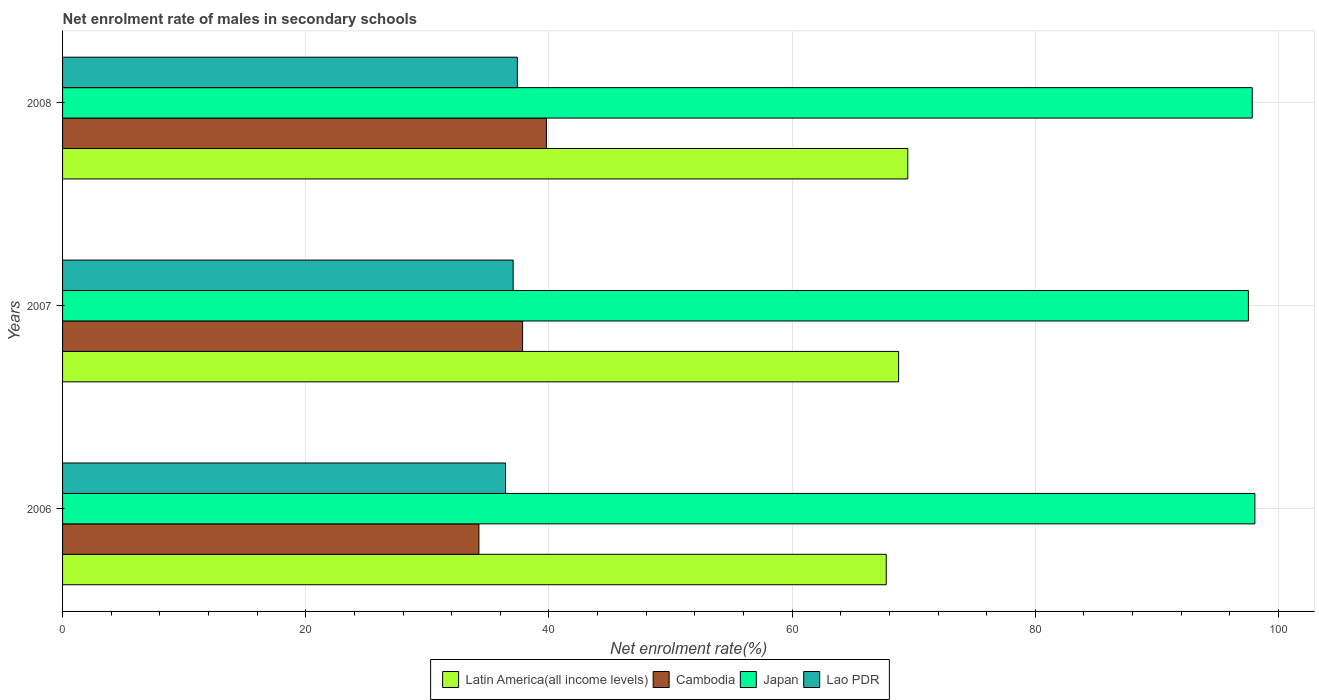How many different coloured bars are there?
Your response must be concise. 4. How many groups of bars are there?
Keep it short and to the point. 3. Are the number of bars on each tick of the Y-axis equal?
Offer a terse response. Yes. How many bars are there on the 2nd tick from the bottom?
Your answer should be compact. 4. What is the net enrolment rate of males in secondary schools in Lao PDR in 2006?
Provide a short and direct response. 36.43. Across all years, what is the maximum net enrolment rate of males in secondary schools in Latin America(all income levels)?
Ensure brevity in your answer.  69.51. Across all years, what is the minimum net enrolment rate of males in secondary schools in Lao PDR?
Make the answer very short. 36.43. What is the total net enrolment rate of males in secondary schools in Japan in the graph?
Your response must be concise. 293.41. What is the difference between the net enrolment rate of males in secondary schools in Latin America(all income levels) in 2006 and that in 2008?
Offer a very short reply. -1.77. What is the difference between the net enrolment rate of males in secondary schools in Latin America(all income levels) in 2008 and the net enrolment rate of males in secondary schools in Lao PDR in 2007?
Make the answer very short. 32.45. What is the average net enrolment rate of males in secondary schools in Lao PDR per year?
Provide a short and direct response. 36.96. In the year 2008, what is the difference between the net enrolment rate of males in secondary schools in Lao PDR and net enrolment rate of males in secondary schools in Latin America(all income levels)?
Provide a short and direct response. -32.11. What is the ratio of the net enrolment rate of males in secondary schools in Lao PDR in 2006 to that in 2008?
Provide a succinct answer. 0.97. Is the net enrolment rate of males in secondary schools in Cambodia in 2006 less than that in 2007?
Your response must be concise. Yes. Is the difference between the net enrolment rate of males in secondary schools in Lao PDR in 2006 and 2007 greater than the difference between the net enrolment rate of males in secondary schools in Latin America(all income levels) in 2006 and 2007?
Offer a terse response. Yes. What is the difference between the highest and the second highest net enrolment rate of males in secondary schools in Latin America(all income levels)?
Your answer should be very brief. 0.75. What is the difference between the highest and the lowest net enrolment rate of males in secondary schools in Lao PDR?
Your answer should be very brief. 0.97. Is it the case that in every year, the sum of the net enrolment rate of males in secondary schools in Latin America(all income levels) and net enrolment rate of males in secondary schools in Japan is greater than the sum of net enrolment rate of males in secondary schools in Lao PDR and net enrolment rate of males in secondary schools in Cambodia?
Keep it short and to the point. Yes. What does the 1st bar from the top in 2007 represents?
Ensure brevity in your answer.  Lao PDR. What does the 3rd bar from the bottom in 2008 represents?
Offer a terse response. Japan. Is it the case that in every year, the sum of the net enrolment rate of males in secondary schools in Lao PDR and net enrolment rate of males in secondary schools in Cambodia is greater than the net enrolment rate of males in secondary schools in Latin America(all income levels)?
Your response must be concise. Yes. Are all the bars in the graph horizontal?
Offer a terse response. Yes. How many years are there in the graph?
Make the answer very short. 3. Does the graph contain any zero values?
Ensure brevity in your answer.  No. Does the graph contain grids?
Your answer should be very brief. Yes. What is the title of the graph?
Offer a very short reply. Net enrolment rate of males in secondary schools. Does "Least developed countries" appear as one of the legend labels in the graph?
Your answer should be compact. No. What is the label or title of the X-axis?
Make the answer very short. Net enrolment rate(%). What is the Net enrolment rate(%) in Latin America(all income levels) in 2006?
Give a very brief answer. 67.74. What is the Net enrolment rate(%) in Cambodia in 2006?
Offer a terse response. 34.24. What is the Net enrolment rate(%) in Japan in 2006?
Provide a succinct answer. 98.05. What is the Net enrolment rate(%) in Lao PDR in 2006?
Your answer should be very brief. 36.43. What is the Net enrolment rate(%) of Latin America(all income levels) in 2007?
Offer a terse response. 68.75. What is the Net enrolment rate(%) in Cambodia in 2007?
Make the answer very short. 37.83. What is the Net enrolment rate(%) of Japan in 2007?
Your answer should be very brief. 97.52. What is the Net enrolment rate(%) in Lao PDR in 2007?
Your response must be concise. 37.06. What is the Net enrolment rate(%) of Latin America(all income levels) in 2008?
Your response must be concise. 69.51. What is the Net enrolment rate(%) in Cambodia in 2008?
Offer a terse response. 39.79. What is the Net enrolment rate(%) of Japan in 2008?
Ensure brevity in your answer.  97.84. What is the Net enrolment rate(%) of Lao PDR in 2008?
Your response must be concise. 37.4. Across all years, what is the maximum Net enrolment rate(%) of Latin America(all income levels)?
Your answer should be compact. 69.51. Across all years, what is the maximum Net enrolment rate(%) in Cambodia?
Your response must be concise. 39.79. Across all years, what is the maximum Net enrolment rate(%) in Japan?
Make the answer very short. 98.05. Across all years, what is the maximum Net enrolment rate(%) in Lao PDR?
Keep it short and to the point. 37.4. Across all years, what is the minimum Net enrolment rate(%) in Latin America(all income levels)?
Offer a terse response. 67.74. Across all years, what is the minimum Net enrolment rate(%) of Cambodia?
Your response must be concise. 34.24. Across all years, what is the minimum Net enrolment rate(%) of Japan?
Provide a short and direct response. 97.52. Across all years, what is the minimum Net enrolment rate(%) in Lao PDR?
Your answer should be very brief. 36.43. What is the total Net enrolment rate(%) in Latin America(all income levels) in the graph?
Your answer should be very brief. 206. What is the total Net enrolment rate(%) in Cambodia in the graph?
Ensure brevity in your answer.  111.86. What is the total Net enrolment rate(%) in Japan in the graph?
Make the answer very short. 293.41. What is the total Net enrolment rate(%) in Lao PDR in the graph?
Offer a very short reply. 110.89. What is the difference between the Net enrolment rate(%) in Latin America(all income levels) in 2006 and that in 2007?
Provide a succinct answer. -1.02. What is the difference between the Net enrolment rate(%) of Cambodia in 2006 and that in 2007?
Your answer should be very brief. -3.59. What is the difference between the Net enrolment rate(%) of Japan in 2006 and that in 2007?
Keep it short and to the point. 0.53. What is the difference between the Net enrolment rate(%) of Lao PDR in 2006 and that in 2007?
Your answer should be compact. -0.62. What is the difference between the Net enrolment rate(%) of Latin America(all income levels) in 2006 and that in 2008?
Your response must be concise. -1.77. What is the difference between the Net enrolment rate(%) in Cambodia in 2006 and that in 2008?
Make the answer very short. -5.55. What is the difference between the Net enrolment rate(%) of Japan in 2006 and that in 2008?
Your answer should be very brief. 0.22. What is the difference between the Net enrolment rate(%) of Lao PDR in 2006 and that in 2008?
Ensure brevity in your answer.  -0.97. What is the difference between the Net enrolment rate(%) of Latin America(all income levels) in 2007 and that in 2008?
Offer a terse response. -0.75. What is the difference between the Net enrolment rate(%) in Cambodia in 2007 and that in 2008?
Offer a terse response. -1.96. What is the difference between the Net enrolment rate(%) of Japan in 2007 and that in 2008?
Give a very brief answer. -0.32. What is the difference between the Net enrolment rate(%) of Lao PDR in 2007 and that in 2008?
Provide a short and direct response. -0.35. What is the difference between the Net enrolment rate(%) of Latin America(all income levels) in 2006 and the Net enrolment rate(%) of Cambodia in 2007?
Your response must be concise. 29.91. What is the difference between the Net enrolment rate(%) of Latin America(all income levels) in 2006 and the Net enrolment rate(%) of Japan in 2007?
Your answer should be very brief. -29.78. What is the difference between the Net enrolment rate(%) in Latin America(all income levels) in 2006 and the Net enrolment rate(%) in Lao PDR in 2007?
Your answer should be very brief. 30.68. What is the difference between the Net enrolment rate(%) of Cambodia in 2006 and the Net enrolment rate(%) of Japan in 2007?
Provide a succinct answer. -63.28. What is the difference between the Net enrolment rate(%) of Cambodia in 2006 and the Net enrolment rate(%) of Lao PDR in 2007?
Provide a succinct answer. -2.82. What is the difference between the Net enrolment rate(%) of Japan in 2006 and the Net enrolment rate(%) of Lao PDR in 2007?
Provide a short and direct response. 61. What is the difference between the Net enrolment rate(%) of Latin America(all income levels) in 2006 and the Net enrolment rate(%) of Cambodia in 2008?
Give a very brief answer. 27.95. What is the difference between the Net enrolment rate(%) in Latin America(all income levels) in 2006 and the Net enrolment rate(%) in Japan in 2008?
Your response must be concise. -30.1. What is the difference between the Net enrolment rate(%) in Latin America(all income levels) in 2006 and the Net enrolment rate(%) in Lao PDR in 2008?
Ensure brevity in your answer.  30.34. What is the difference between the Net enrolment rate(%) in Cambodia in 2006 and the Net enrolment rate(%) in Japan in 2008?
Provide a short and direct response. -63.6. What is the difference between the Net enrolment rate(%) in Cambodia in 2006 and the Net enrolment rate(%) in Lao PDR in 2008?
Your response must be concise. -3.16. What is the difference between the Net enrolment rate(%) of Japan in 2006 and the Net enrolment rate(%) of Lao PDR in 2008?
Your answer should be very brief. 60.65. What is the difference between the Net enrolment rate(%) of Latin America(all income levels) in 2007 and the Net enrolment rate(%) of Cambodia in 2008?
Offer a very short reply. 28.96. What is the difference between the Net enrolment rate(%) in Latin America(all income levels) in 2007 and the Net enrolment rate(%) in Japan in 2008?
Keep it short and to the point. -29.08. What is the difference between the Net enrolment rate(%) in Latin America(all income levels) in 2007 and the Net enrolment rate(%) in Lao PDR in 2008?
Make the answer very short. 31.35. What is the difference between the Net enrolment rate(%) in Cambodia in 2007 and the Net enrolment rate(%) in Japan in 2008?
Give a very brief answer. -60. What is the difference between the Net enrolment rate(%) of Cambodia in 2007 and the Net enrolment rate(%) of Lao PDR in 2008?
Offer a terse response. 0.43. What is the difference between the Net enrolment rate(%) of Japan in 2007 and the Net enrolment rate(%) of Lao PDR in 2008?
Your answer should be compact. 60.12. What is the average Net enrolment rate(%) in Latin America(all income levels) per year?
Your answer should be compact. 68.67. What is the average Net enrolment rate(%) in Cambodia per year?
Provide a succinct answer. 37.29. What is the average Net enrolment rate(%) of Japan per year?
Ensure brevity in your answer.  97.8. What is the average Net enrolment rate(%) of Lao PDR per year?
Ensure brevity in your answer.  36.96. In the year 2006, what is the difference between the Net enrolment rate(%) in Latin America(all income levels) and Net enrolment rate(%) in Cambodia?
Offer a very short reply. 33.5. In the year 2006, what is the difference between the Net enrolment rate(%) of Latin America(all income levels) and Net enrolment rate(%) of Japan?
Ensure brevity in your answer.  -30.32. In the year 2006, what is the difference between the Net enrolment rate(%) in Latin America(all income levels) and Net enrolment rate(%) in Lao PDR?
Keep it short and to the point. 31.31. In the year 2006, what is the difference between the Net enrolment rate(%) of Cambodia and Net enrolment rate(%) of Japan?
Your answer should be very brief. -63.81. In the year 2006, what is the difference between the Net enrolment rate(%) of Cambodia and Net enrolment rate(%) of Lao PDR?
Provide a short and direct response. -2.19. In the year 2006, what is the difference between the Net enrolment rate(%) of Japan and Net enrolment rate(%) of Lao PDR?
Provide a succinct answer. 61.62. In the year 2007, what is the difference between the Net enrolment rate(%) of Latin America(all income levels) and Net enrolment rate(%) of Cambodia?
Your answer should be very brief. 30.92. In the year 2007, what is the difference between the Net enrolment rate(%) in Latin America(all income levels) and Net enrolment rate(%) in Japan?
Give a very brief answer. -28.76. In the year 2007, what is the difference between the Net enrolment rate(%) of Latin America(all income levels) and Net enrolment rate(%) of Lao PDR?
Provide a short and direct response. 31.7. In the year 2007, what is the difference between the Net enrolment rate(%) in Cambodia and Net enrolment rate(%) in Japan?
Keep it short and to the point. -59.69. In the year 2007, what is the difference between the Net enrolment rate(%) of Cambodia and Net enrolment rate(%) of Lao PDR?
Ensure brevity in your answer.  0.78. In the year 2007, what is the difference between the Net enrolment rate(%) of Japan and Net enrolment rate(%) of Lao PDR?
Make the answer very short. 60.46. In the year 2008, what is the difference between the Net enrolment rate(%) in Latin America(all income levels) and Net enrolment rate(%) in Cambodia?
Give a very brief answer. 29.72. In the year 2008, what is the difference between the Net enrolment rate(%) in Latin America(all income levels) and Net enrolment rate(%) in Japan?
Make the answer very short. -28.33. In the year 2008, what is the difference between the Net enrolment rate(%) in Latin America(all income levels) and Net enrolment rate(%) in Lao PDR?
Make the answer very short. 32.11. In the year 2008, what is the difference between the Net enrolment rate(%) in Cambodia and Net enrolment rate(%) in Japan?
Your answer should be compact. -58.05. In the year 2008, what is the difference between the Net enrolment rate(%) of Cambodia and Net enrolment rate(%) of Lao PDR?
Your answer should be very brief. 2.39. In the year 2008, what is the difference between the Net enrolment rate(%) of Japan and Net enrolment rate(%) of Lao PDR?
Your answer should be compact. 60.43. What is the ratio of the Net enrolment rate(%) in Latin America(all income levels) in 2006 to that in 2007?
Provide a short and direct response. 0.99. What is the ratio of the Net enrolment rate(%) of Cambodia in 2006 to that in 2007?
Your answer should be very brief. 0.91. What is the ratio of the Net enrolment rate(%) of Japan in 2006 to that in 2007?
Ensure brevity in your answer.  1.01. What is the ratio of the Net enrolment rate(%) in Lao PDR in 2006 to that in 2007?
Your answer should be very brief. 0.98. What is the ratio of the Net enrolment rate(%) in Latin America(all income levels) in 2006 to that in 2008?
Your answer should be compact. 0.97. What is the ratio of the Net enrolment rate(%) in Cambodia in 2006 to that in 2008?
Make the answer very short. 0.86. What is the ratio of the Net enrolment rate(%) in Lao PDR in 2006 to that in 2008?
Offer a terse response. 0.97. What is the ratio of the Net enrolment rate(%) in Cambodia in 2007 to that in 2008?
Offer a very short reply. 0.95. What is the ratio of the Net enrolment rate(%) of Japan in 2007 to that in 2008?
Make the answer very short. 1. What is the difference between the highest and the second highest Net enrolment rate(%) in Latin America(all income levels)?
Provide a short and direct response. 0.75. What is the difference between the highest and the second highest Net enrolment rate(%) in Cambodia?
Keep it short and to the point. 1.96. What is the difference between the highest and the second highest Net enrolment rate(%) of Japan?
Offer a very short reply. 0.22. What is the difference between the highest and the second highest Net enrolment rate(%) in Lao PDR?
Provide a succinct answer. 0.35. What is the difference between the highest and the lowest Net enrolment rate(%) in Latin America(all income levels)?
Offer a very short reply. 1.77. What is the difference between the highest and the lowest Net enrolment rate(%) in Cambodia?
Your answer should be compact. 5.55. What is the difference between the highest and the lowest Net enrolment rate(%) of Japan?
Your response must be concise. 0.53. What is the difference between the highest and the lowest Net enrolment rate(%) in Lao PDR?
Provide a succinct answer. 0.97. 